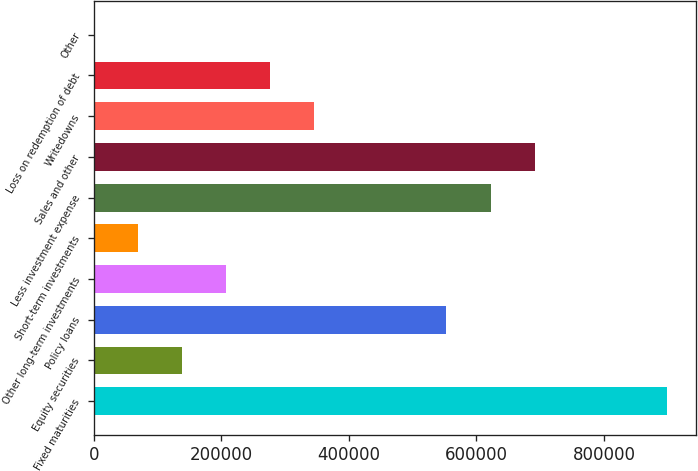Convert chart to OTSL. <chart><loc_0><loc_0><loc_500><loc_500><bar_chart><fcel>Fixed maturities<fcel>Equity securities<fcel>Policy loans<fcel>Other long-term investments<fcel>Short-term investments<fcel>Less investment expense<fcel>Sales and other<fcel>Writedowns<fcel>Loss on redemption of debt<fcel>Other<nl><fcel>898539<fcel>138403<fcel>553023<fcel>207507<fcel>69300.2<fcel>622126<fcel>691229<fcel>345713<fcel>276610<fcel>197<nl></chart> 